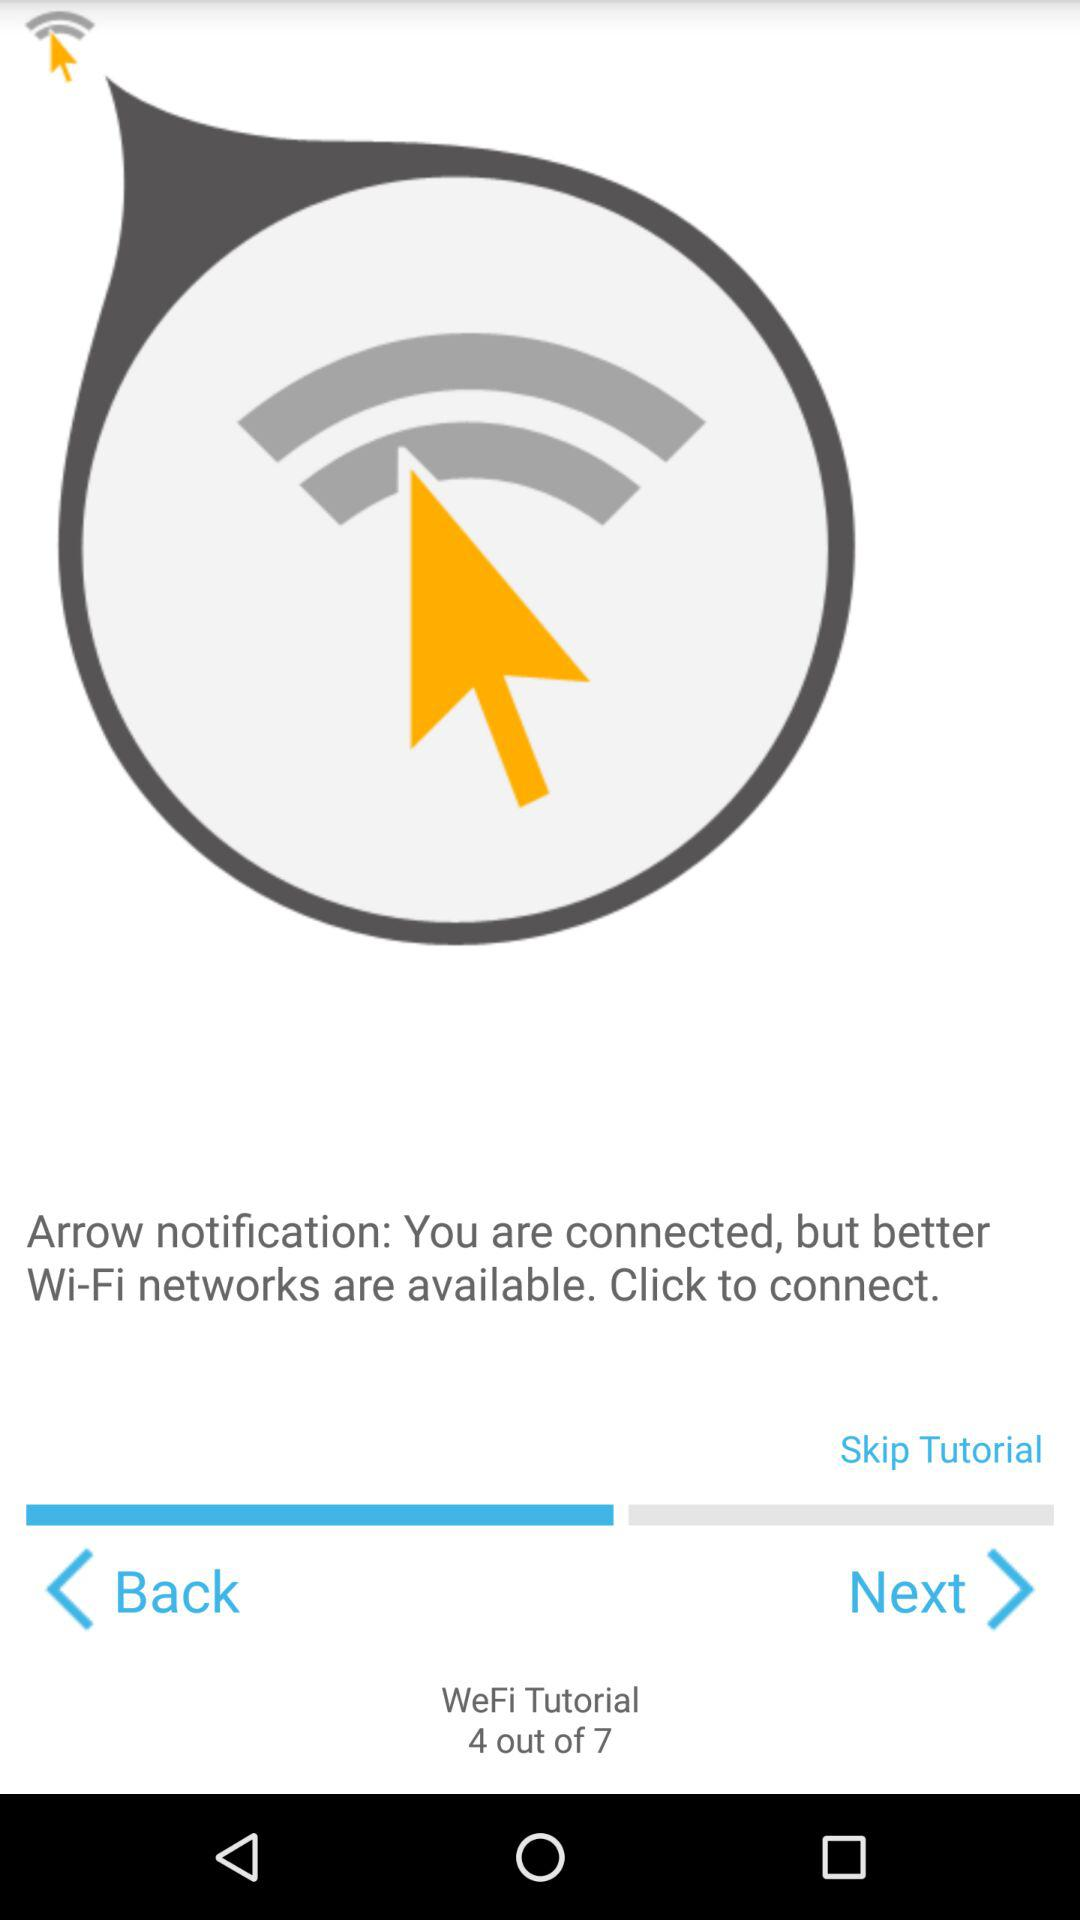How many arrows are pointing upwards?
Answer the question using a single word or phrase. 2 